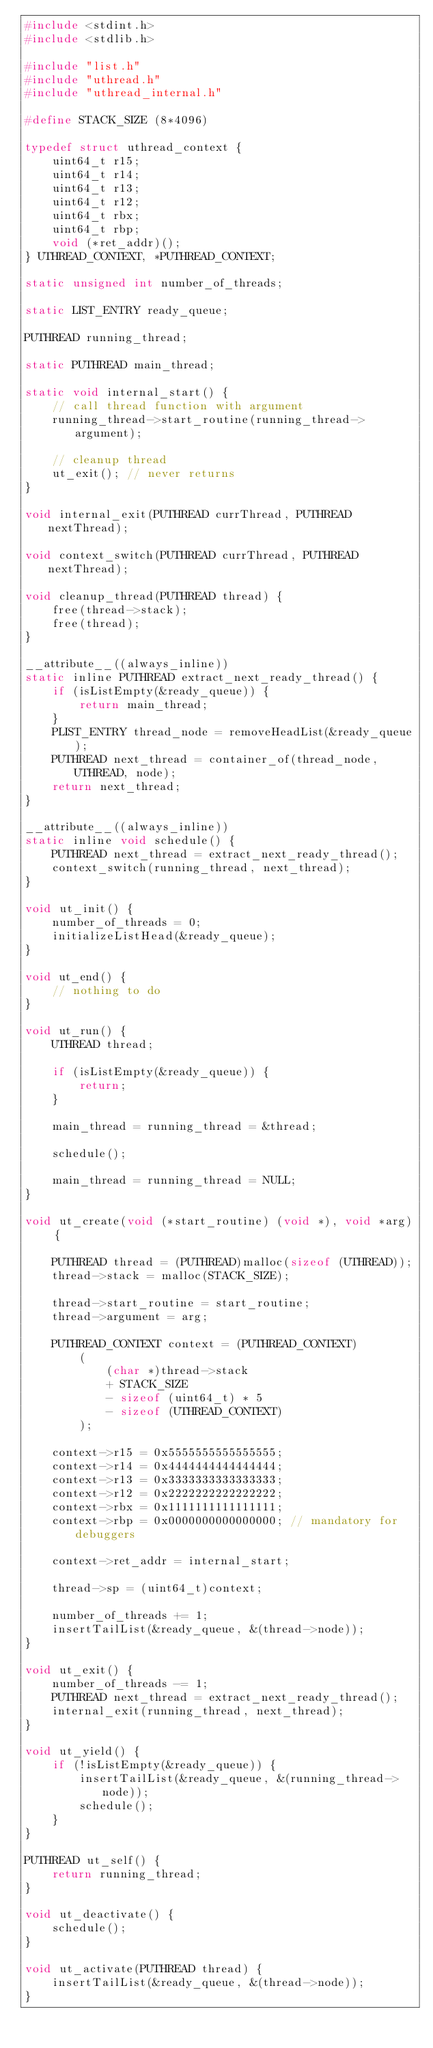Convert code to text. <code><loc_0><loc_0><loc_500><loc_500><_C_>#include <stdint.h>
#include <stdlib.h>

#include "list.h"
#include "uthread.h"
#include "uthread_internal.h"

#define STACK_SIZE (8*4096)

typedef struct uthread_context {
	uint64_t r15;
	uint64_t r14;
	uint64_t r13;
	uint64_t r12;
	uint64_t rbx;
	uint64_t rbp;
	void (*ret_addr)();
} UTHREAD_CONTEXT, *PUTHREAD_CONTEXT;

static unsigned int number_of_threads;

static LIST_ENTRY ready_queue;

PUTHREAD running_thread;

static PUTHREAD main_thread;

static void internal_start() {
	// call thread function with argument
	running_thread->start_routine(running_thread->argument);

	// cleanup thread
	ut_exit(); // never returns
}

void internal_exit(PUTHREAD currThread, PUTHREAD nextThread);

void context_switch(PUTHREAD currThread, PUTHREAD nextThread);

void cleanup_thread(PUTHREAD thread) {
	free(thread->stack);
	free(thread);
}

__attribute__((always_inline))
static inline PUTHREAD extract_next_ready_thread() {
	if (isListEmpty(&ready_queue)) {
		return main_thread;
	}
	PLIST_ENTRY thread_node = removeHeadList(&ready_queue);
	PUTHREAD next_thread = container_of(thread_node, UTHREAD, node);
	return next_thread;
}

__attribute__((always_inline))
static inline void schedule() {
	PUTHREAD next_thread = extract_next_ready_thread();
	context_switch(running_thread, next_thread);
}

void ut_init() {
	number_of_threads = 0;
	initializeListHead(&ready_queue);
}

void ut_end() {
	// nothing to do
}

void ut_run() {
	UTHREAD thread;
	
	if (isListEmpty(&ready_queue)) {
		return;
	}
	
	main_thread = running_thread = &thread;
	
	schedule();

	main_thread = running_thread = NULL;
}

void ut_create(void (*start_routine) (void *), void *arg) {
	
	PUTHREAD thread = (PUTHREAD)malloc(sizeof (UTHREAD));
	thread->stack = malloc(STACK_SIZE);
	
	thread->start_routine = start_routine;
	thread->argument = arg;
	
	PUTHREAD_CONTEXT context = (PUTHREAD_CONTEXT)
		(
			(char *)thread->stack
			+ STACK_SIZE
			- sizeof (uint64_t) * 5
			- sizeof (UTHREAD_CONTEXT)
		);

	context->r15 = 0x5555555555555555;
	context->r14 = 0x4444444444444444;
	context->r13 = 0x3333333333333333;
	context->r12 = 0x2222222222222222;
	context->rbx = 0x1111111111111111;
	context->rbp = 0x0000000000000000; // mandatory for debuggers
	
	context->ret_addr = internal_start;
	
	thread->sp = (uint64_t)context;
	
	number_of_threads += 1;
	insertTailList(&ready_queue, &(thread->node));
}

void ut_exit() {
	number_of_threads -= 1;
	PUTHREAD next_thread = extract_next_ready_thread();
	internal_exit(running_thread, next_thread);
}

void ut_yield() {
	if (!isListEmpty(&ready_queue)) {
		insertTailList(&ready_queue, &(running_thread->node));
		schedule();
	}
}

PUTHREAD ut_self() {
	return running_thread;
}

void ut_deactivate() {
	schedule();
}

void ut_activate(PUTHREAD thread) {
	insertTailList(&ready_queue, &(thread->node));
}
</code> 